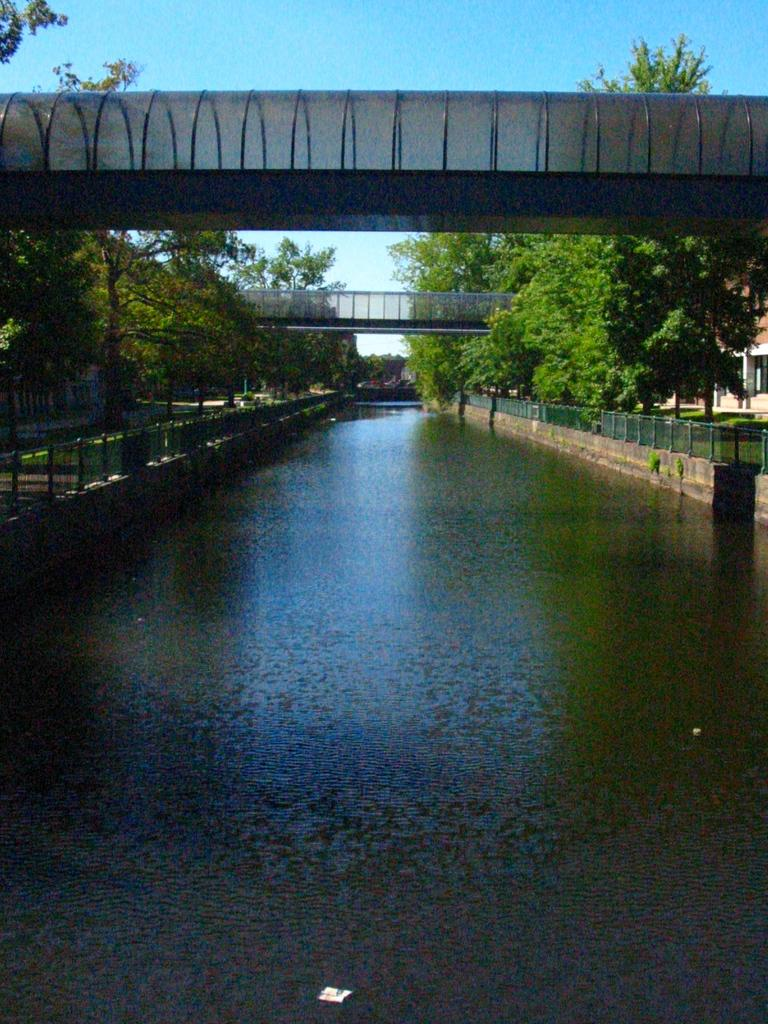What is in the foreground of the image? There is a water surface in the foreground of the image. What can be seen in the image besides the water surface? There are trees, a bridge, boundaries, a house, and the sky visible in the image. Can you describe the bridge in the image? It appears to be a bridge in the image. What is the location of the house in the image? The house is in the background of the image. What is visible in the sky in the image? The sky is visible in the background of the image. How many spiders are crawling on the bridge in the image? There are no spiders visible in the image; it features a water surface, trees, a bridge, boundaries, a house, and the sky. Is there a horse running through the water in the image? There is no horse present in the image; it features a water surface, trees, a bridge, boundaries, a house, and the sky. 